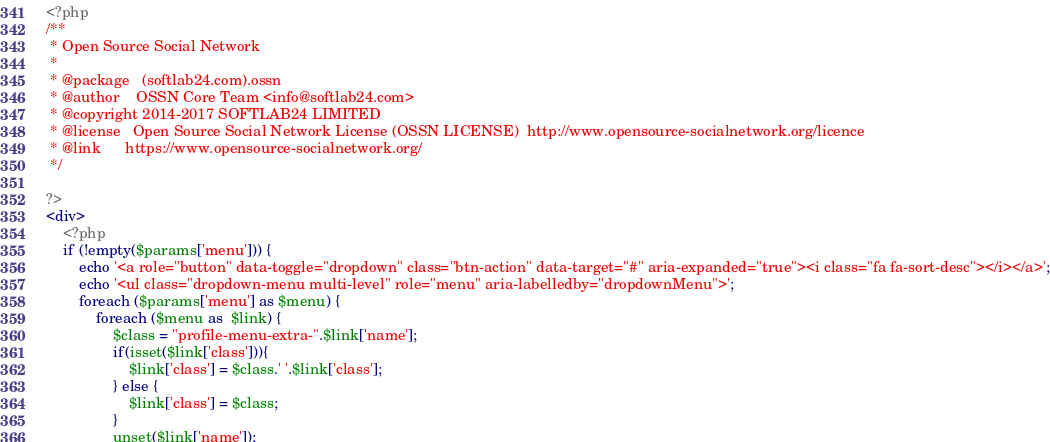Convert code to text. <code><loc_0><loc_0><loc_500><loc_500><_PHP_><?php
/**
 * Open Source Social Network
 *
 * @package   (softlab24.com).ossn
 * @author    OSSN Core Team <info@softlab24.com>
 * @copyright 2014-2017 SOFTLAB24 LIMITED
 * @license   Open Source Social Network License (OSSN LICENSE)  http://www.opensource-socialnetwork.org/licence
 * @link      https://www.opensource-socialnetwork.org/
 */
 
?>
<div>
    <?php
    if (!empty($params['menu'])) {
		echo '<a role="button" data-toggle="dropdown" class="btn-action" data-target="#" aria-expanded="true"><i class="fa fa-sort-desc"></i></a>';
		echo '<ul class="dropdown-menu multi-level" role="menu" aria-labelledby="dropdownMenu">';
        foreach ($params['menu'] as $menu) {
            foreach ($menu as  $link) {
				$class = "profile-menu-extra-".$link['name'];
				if(isset($link['class'])){
					$link['class'] = $class.' '.$link['class'];	
				} else {
					$link['class'] = $class;
				}
				unset($link['name']);</code> 